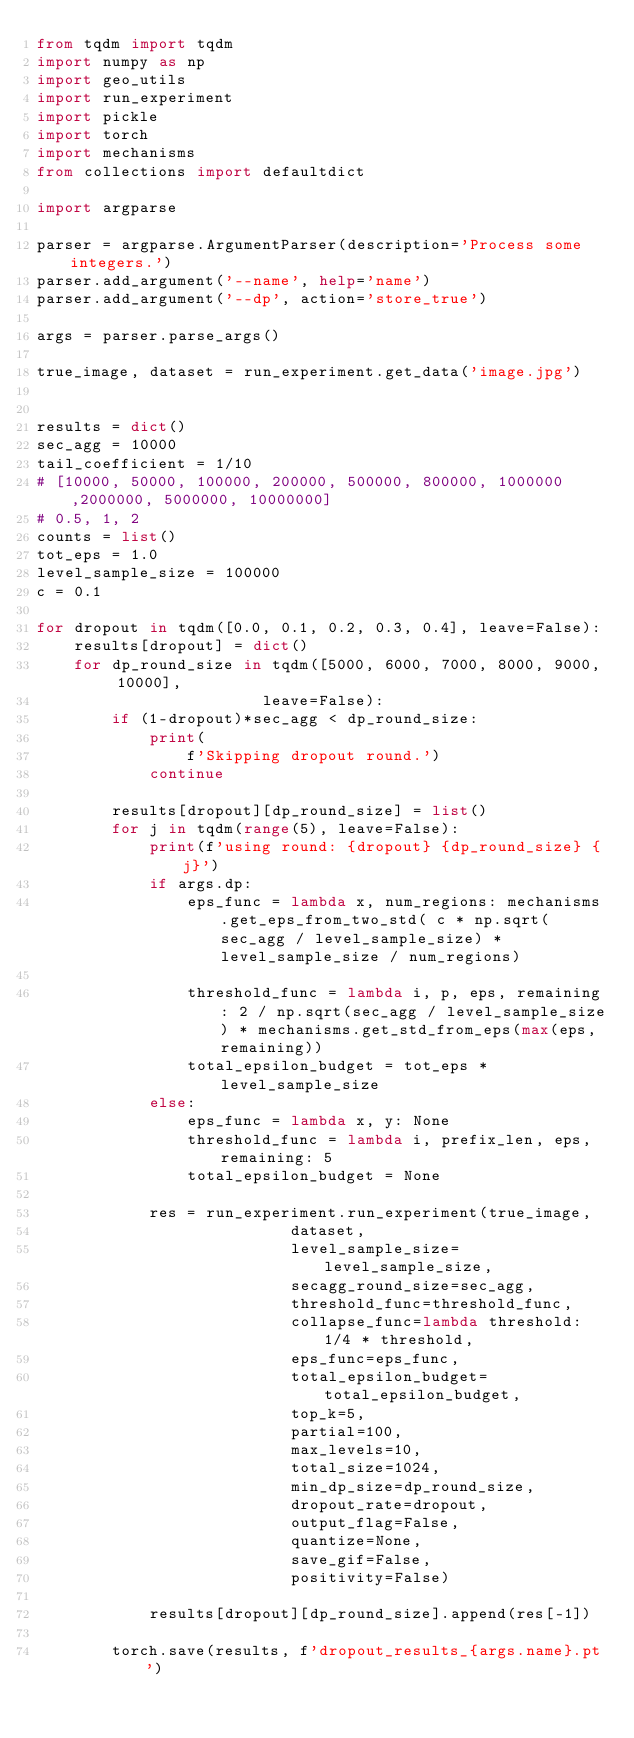<code> <loc_0><loc_0><loc_500><loc_500><_Python_>from tqdm import tqdm
import numpy as np
import geo_utils
import run_experiment
import pickle
import torch
import mechanisms
from collections import defaultdict

import argparse

parser = argparse.ArgumentParser(description='Process some integers.')
parser.add_argument('--name', help='name')
parser.add_argument('--dp', action='store_true')

args = parser.parse_args()

true_image, dataset = run_experiment.get_data('image.jpg')


results = dict()
sec_agg = 10000
tail_coefficient = 1/10
# [10000, 50000, 100000, 200000, 500000, 800000, 1000000 ,2000000, 5000000, 10000000]
# 0.5, 1, 2
counts = list()
tot_eps = 1.0
level_sample_size = 100000
c = 0.1

for dropout in tqdm([0.0, 0.1, 0.2, 0.3, 0.4], leave=False):
    results[dropout] = dict()
    for dp_round_size in tqdm([5000, 6000, 7000, 8000, 9000, 10000],
                        leave=False):
        if (1-dropout)*sec_agg < dp_round_size:
            print(
                f'Skipping dropout round.')
            continue

        results[dropout][dp_round_size] = list()
        for j in tqdm(range(5), leave=False):
            print(f'using round: {dropout} {dp_round_size} {j}')
            if args.dp:
                eps_func = lambda x, num_regions: mechanisms.get_eps_from_two_std( c * np.sqrt(sec_agg / level_sample_size) * level_sample_size / num_regions)

                threshold_func = lambda i, p, eps, remaining: 2 / np.sqrt(sec_agg / level_sample_size) * mechanisms.get_std_from_eps(max(eps, remaining))
                total_epsilon_budget = tot_eps * level_sample_size
            else:
                eps_func = lambda x, y: None
                threshold_func = lambda i, prefix_len, eps, remaining: 5
                total_epsilon_budget = None

            res = run_experiment.run_experiment(true_image,
                           dataset,
                           level_sample_size=level_sample_size,
                           secagg_round_size=sec_agg,
                           threshold_func=threshold_func,
                           collapse_func=lambda threshold: 1/4 * threshold,
                           eps_func=eps_func,
                           total_epsilon_budget=total_epsilon_budget,
                           top_k=5,
                           partial=100,
                           max_levels=10,
                           total_size=1024,
                           min_dp_size=dp_round_size,
                           dropout_rate=dropout,
                           output_flag=False,
                           quantize=None,
                           save_gif=False,
                           positivity=False)

            results[dropout][dp_round_size].append(res[-1])

        torch.save(results, f'dropout_results_{args.name}.pt')</code> 